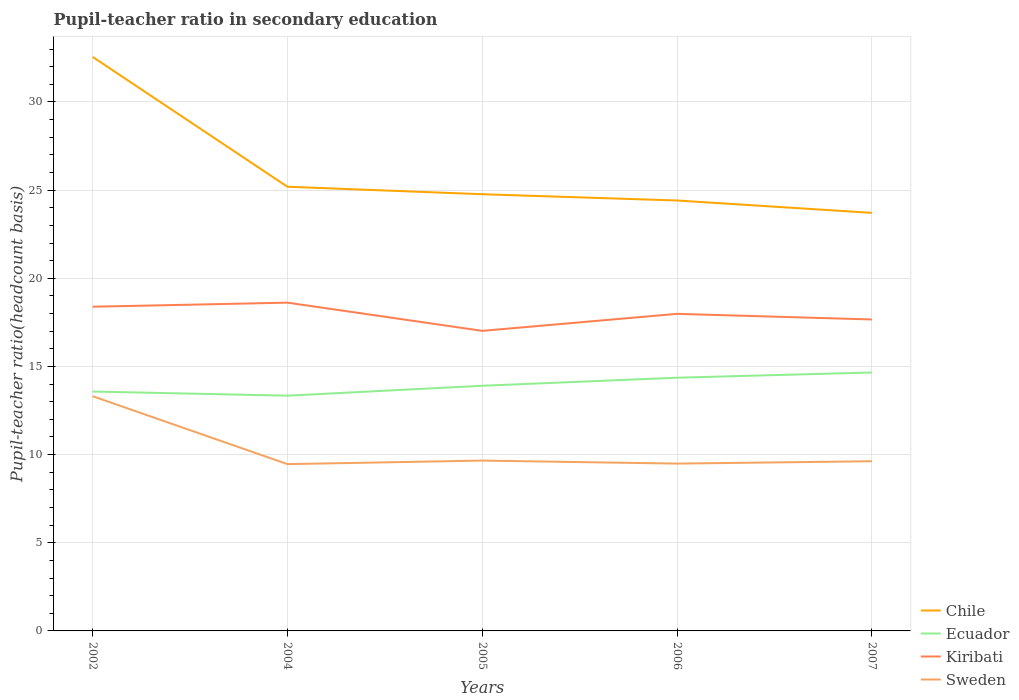Does the line corresponding to Chile intersect with the line corresponding to Kiribati?
Give a very brief answer. No. Across all years, what is the maximum pupil-teacher ratio in secondary education in Chile?
Your response must be concise. 23.71. What is the total pupil-teacher ratio in secondary education in Ecuador in the graph?
Keep it short and to the point. -1.31. What is the difference between the highest and the second highest pupil-teacher ratio in secondary education in Sweden?
Provide a succinct answer. 3.85. How many years are there in the graph?
Give a very brief answer. 5. What is the difference between two consecutive major ticks on the Y-axis?
Your answer should be compact. 5. Are the values on the major ticks of Y-axis written in scientific E-notation?
Keep it short and to the point. No. Does the graph contain grids?
Ensure brevity in your answer.  Yes. What is the title of the graph?
Offer a terse response. Pupil-teacher ratio in secondary education. Does "Malawi" appear as one of the legend labels in the graph?
Keep it short and to the point. No. What is the label or title of the X-axis?
Give a very brief answer. Years. What is the label or title of the Y-axis?
Offer a terse response. Pupil-teacher ratio(headcount basis). What is the Pupil-teacher ratio(headcount basis) of Chile in 2002?
Your answer should be compact. 32.56. What is the Pupil-teacher ratio(headcount basis) in Ecuador in 2002?
Your response must be concise. 13.58. What is the Pupil-teacher ratio(headcount basis) in Kiribati in 2002?
Provide a short and direct response. 18.39. What is the Pupil-teacher ratio(headcount basis) in Sweden in 2002?
Offer a terse response. 13.31. What is the Pupil-teacher ratio(headcount basis) of Chile in 2004?
Your response must be concise. 25.19. What is the Pupil-teacher ratio(headcount basis) of Ecuador in 2004?
Keep it short and to the point. 13.34. What is the Pupil-teacher ratio(headcount basis) of Kiribati in 2004?
Make the answer very short. 18.62. What is the Pupil-teacher ratio(headcount basis) of Sweden in 2004?
Ensure brevity in your answer.  9.46. What is the Pupil-teacher ratio(headcount basis) in Chile in 2005?
Provide a short and direct response. 24.77. What is the Pupil-teacher ratio(headcount basis) of Ecuador in 2005?
Your answer should be compact. 13.9. What is the Pupil-teacher ratio(headcount basis) of Kiribati in 2005?
Offer a very short reply. 17.02. What is the Pupil-teacher ratio(headcount basis) of Sweden in 2005?
Your response must be concise. 9.66. What is the Pupil-teacher ratio(headcount basis) in Chile in 2006?
Your answer should be compact. 24.41. What is the Pupil-teacher ratio(headcount basis) in Ecuador in 2006?
Your answer should be compact. 14.36. What is the Pupil-teacher ratio(headcount basis) in Kiribati in 2006?
Ensure brevity in your answer.  17.98. What is the Pupil-teacher ratio(headcount basis) of Sweden in 2006?
Offer a terse response. 9.49. What is the Pupil-teacher ratio(headcount basis) of Chile in 2007?
Give a very brief answer. 23.71. What is the Pupil-teacher ratio(headcount basis) of Ecuador in 2007?
Give a very brief answer. 14.66. What is the Pupil-teacher ratio(headcount basis) in Kiribati in 2007?
Make the answer very short. 17.66. What is the Pupil-teacher ratio(headcount basis) in Sweden in 2007?
Offer a very short reply. 9.62. Across all years, what is the maximum Pupil-teacher ratio(headcount basis) in Chile?
Provide a succinct answer. 32.56. Across all years, what is the maximum Pupil-teacher ratio(headcount basis) of Ecuador?
Ensure brevity in your answer.  14.66. Across all years, what is the maximum Pupil-teacher ratio(headcount basis) in Kiribati?
Your answer should be very brief. 18.62. Across all years, what is the maximum Pupil-teacher ratio(headcount basis) of Sweden?
Provide a succinct answer. 13.31. Across all years, what is the minimum Pupil-teacher ratio(headcount basis) in Chile?
Offer a terse response. 23.71. Across all years, what is the minimum Pupil-teacher ratio(headcount basis) of Ecuador?
Make the answer very short. 13.34. Across all years, what is the minimum Pupil-teacher ratio(headcount basis) in Kiribati?
Your answer should be compact. 17.02. Across all years, what is the minimum Pupil-teacher ratio(headcount basis) of Sweden?
Your answer should be compact. 9.46. What is the total Pupil-teacher ratio(headcount basis) of Chile in the graph?
Keep it short and to the point. 130.64. What is the total Pupil-teacher ratio(headcount basis) in Ecuador in the graph?
Your answer should be very brief. 69.84. What is the total Pupil-teacher ratio(headcount basis) of Kiribati in the graph?
Your answer should be compact. 89.67. What is the total Pupil-teacher ratio(headcount basis) of Sweden in the graph?
Make the answer very short. 51.55. What is the difference between the Pupil-teacher ratio(headcount basis) of Chile in 2002 and that in 2004?
Your answer should be very brief. 7.36. What is the difference between the Pupil-teacher ratio(headcount basis) in Ecuador in 2002 and that in 2004?
Provide a short and direct response. 0.23. What is the difference between the Pupil-teacher ratio(headcount basis) in Kiribati in 2002 and that in 2004?
Your answer should be very brief. -0.23. What is the difference between the Pupil-teacher ratio(headcount basis) of Sweden in 2002 and that in 2004?
Your answer should be compact. 3.85. What is the difference between the Pupil-teacher ratio(headcount basis) in Chile in 2002 and that in 2005?
Ensure brevity in your answer.  7.79. What is the difference between the Pupil-teacher ratio(headcount basis) of Ecuador in 2002 and that in 2005?
Keep it short and to the point. -0.33. What is the difference between the Pupil-teacher ratio(headcount basis) in Kiribati in 2002 and that in 2005?
Provide a succinct answer. 1.37. What is the difference between the Pupil-teacher ratio(headcount basis) in Sweden in 2002 and that in 2005?
Provide a succinct answer. 3.65. What is the difference between the Pupil-teacher ratio(headcount basis) in Chile in 2002 and that in 2006?
Your answer should be compact. 8.14. What is the difference between the Pupil-teacher ratio(headcount basis) of Ecuador in 2002 and that in 2006?
Your response must be concise. -0.78. What is the difference between the Pupil-teacher ratio(headcount basis) of Kiribati in 2002 and that in 2006?
Keep it short and to the point. 0.4. What is the difference between the Pupil-teacher ratio(headcount basis) of Sweden in 2002 and that in 2006?
Make the answer very short. 3.82. What is the difference between the Pupil-teacher ratio(headcount basis) of Chile in 2002 and that in 2007?
Offer a very short reply. 8.84. What is the difference between the Pupil-teacher ratio(headcount basis) of Ecuador in 2002 and that in 2007?
Give a very brief answer. -1.08. What is the difference between the Pupil-teacher ratio(headcount basis) of Kiribati in 2002 and that in 2007?
Keep it short and to the point. 0.72. What is the difference between the Pupil-teacher ratio(headcount basis) of Sweden in 2002 and that in 2007?
Your answer should be compact. 3.69. What is the difference between the Pupil-teacher ratio(headcount basis) in Chile in 2004 and that in 2005?
Offer a terse response. 0.42. What is the difference between the Pupil-teacher ratio(headcount basis) of Ecuador in 2004 and that in 2005?
Offer a terse response. -0.56. What is the difference between the Pupil-teacher ratio(headcount basis) of Kiribati in 2004 and that in 2005?
Offer a terse response. 1.6. What is the difference between the Pupil-teacher ratio(headcount basis) in Sweden in 2004 and that in 2005?
Make the answer very short. -0.2. What is the difference between the Pupil-teacher ratio(headcount basis) in Chile in 2004 and that in 2006?
Ensure brevity in your answer.  0.78. What is the difference between the Pupil-teacher ratio(headcount basis) of Ecuador in 2004 and that in 2006?
Make the answer very short. -1.02. What is the difference between the Pupil-teacher ratio(headcount basis) in Kiribati in 2004 and that in 2006?
Provide a short and direct response. 0.63. What is the difference between the Pupil-teacher ratio(headcount basis) in Sweden in 2004 and that in 2006?
Offer a terse response. -0.03. What is the difference between the Pupil-teacher ratio(headcount basis) in Chile in 2004 and that in 2007?
Your answer should be compact. 1.48. What is the difference between the Pupil-teacher ratio(headcount basis) of Ecuador in 2004 and that in 2007?
Your response must be concise. -1.31. What is the difference between the Pupil-teacher ratio(headcount basis) of Kiribati in 2004 and that in 2007?
Your response must be concise. 0.95. What is the difference between the Pupil-teacher ratio(headcount basis) in Sweden in 2004 and that in 2007?
Offer a terse response. -0.16. What is the difference between the Pupil-teacher ratio(headcount basis) of Chile in 2005 and that in 2006?
Make the answer very short. 0.36. What is the difference between the Pupil-teacher ratio(headcount basis) of Ecuador in 2005 and that in 2006?
Keep it short and to the point. -0.46. What is the difference between the Pupil-teacher ratio(headcount basis) of Kiribati in 2005 and that in 2006?
Give a very brief answer. -0.96. What is the difference between the Pupil-teacher ratio(headcount basis) of Sweden in 2005 and that in 2006?
Make the answer very short. 0.17. What is the difference between the Pupil-teacher ratio(headcount basis) of Chile in 2005 and that in 2007?
Provide a succinct answer. 1.06. What is the difference between the Pupil-teacher ratio(headcount basis) in Ecuador in 2005 and that in 2007?
Ensure brevity in your answer.  -0.75. What is the difference between the Pupil-teacher ratio(headcount basis) in Kiribati in 2005 and that in 2007?
Offer a very short reply. -0.65. What is the difference between the Pupil-teacher ratio(headcount basis) in Sweden in 2005 and that in 2007?
Offer a very short reply. 0.04. What is the difference between the Pupil-teacher ratio(headcount basis) in Chile in 2006 and that in 2007?
Ensure brevity in your answer.  0.7. What is the difference between the Pupil-teacher ratio(headcount basis) in Ecuador in 2006 and that in 2007?
Your response must be concise. -0.3. What is the difference between the Pupil-teacher ratio(headcount basis) of Kiribati in 2006 and that in 2007?
Give a very brief answer. 0.32. What is the difference between the Pupil-teacher ratio(headcount basis) in Sweden in 2006 and that in 2007?
Provide a succinct answer. -0.13. What is the difference between the Pupil-teacher ratio(headcount basis) of Chile in 2002 and the Pupil-teacher ratio(headcount basis) of Ecuador in 2004?
Provide a short and direct response. 19.21. What is the difference between the Pupil-teacher ratio(headcount basis) in Chile in 2002 and the Pupil-teacher ratio(headcount basis) in Kiribati in 2004?
Offer a very short reply. 13.94. What is the difference between the Pupil-teacher ratio(headcount basis) of Chile in 2002 and the Pupil-teacher ratio(headcount basis) of Sweden in 2004?
Make the answer very short. 23.1. What is the difference between the Pupil-teacher ratio(headcount basis) of Ecuador in 2002 and the Pupil-teacher ratio(headcount basis) of Kiribati in 2004?
Make the answer very short. -5.04. What is the difference between the Pupil-teacher ratio(headcount basis) in Ecuador in 2002 and the Pupil-teacher ratio(headcount basis) in Sweden in 2004?
Provide a succinct answer. 4.12. What is the difference between the Pupil-teacher ratio(headcount basis) of Kiribati in 2002 and the Pupil-teacher ratio(headcount basis) of Sweden in 2004?
Your answer should be very brief. 8.93. What is the difference between the Pupil-teacher ratio(headcount basis) of Chile in 2002 and the Pupil-teacher ratio(headcount basis) of Ecuador in 2005?
Offer a very short reply. 18.65. What is the difference between the Pupil-teacher ratio(headcount basis) of Chile in 2002 and the Pupil-teacher ratio(headcount basis) of Kiribati in 2005?
Give a very brief answer. 15.54. What is the difference between the Pupil-teacher ratio(headcount basis) of Chile in 2002 and the Pupil-teacher ratio(headcount basis) of Sweden in 2005?
Your answer should be compact. 22.89. What is the difference between the Pupil-teacher ratio(headcount basis) of Ecuador in 2002 and the Pupil-teacher ratio(headcount basis) of Kiribati in 2005?
Make the answer very short. -3.44. What is the difference between the Pupil-teacher ratio(headcount basis) in Ecuador in 2002 and the Pupil-teacher ratio(headcount basis) in Sweden in 2005?
Your answer should be compact. 3.92. What is the difference between the Pupil-teacher ratio(headcount basis) of Kiribati in 2002 and the Pupil-teacher ratio(headcount basis) of Sweden in 2005?
Offer a terse response. 8.73. What is the difference between the Pupil-teacher ratio(headcount basis) in Chile in 2002 and the Pupil-teacher ratio(headcount basis) in Ecuador in 2006?
Offer a terse response. 18.19. What is the difference between the Pupil-teacher ratio(headcount basis) of Chile in 2002 and the Pupil-teacher ratio(headcount basis) of Kiribati in 2006?
Ensure brevity in your answer.  14.57. What is the difference between the Pupil-teacher ratio(headcount basis) of Chile in 2002 and the Pupil-teacher ratio(headcount basis) of Sweden in 2006?
Make the answer very short. 23.06. What is the difference between the Pupil-teacher ratio(headcount basis) of Ecuador in 2002 and the Pupil-teacher ratio(headcount basis) of Kiribati in 2006?
Offer a terse response. -4.41. What is the difference between the Pupil-teacher ratio(headcount basis) in Ecuador in 2002 and the Pupil-teacher ratio(headcount basis) in Sweden in 2006?
Provide a short and direct response. 4.09. What is the difference between the Pupil-teacher ratio(headcount basis) in Kiribati in 2002 and the Pupil-teacher ratio(headcount basis) in Sweden in 2006?
Your answer should be compact. 8.9. What is the difference between the Pupil-teacher ratio(headcount basis) of Chile in 2002 and the Pupil-teacher ratio(headcount basis) of Ecuador in 2007?
Your answer should be very brief. 17.9. What is the difference between the Pupil-teacher ratio(headcount basis) of Chile in 2002 and the Pupil-teacher ratio(headcount basis) of Kiribati in 2007?
Ensure brevity in your answer.  14.89. What is the difference between the Pupil-teacher ratio(headcount basis) of Chile in 2002 and the Pupil-teacher ratio(headcount basis) of Sweden in 2007?
Offer a terse response. 22.93. What is the difference between the Pupil-teacher ratio(headcount basis) in Ecuador in 2002 and the Pupil-teacher ratio(headcount basis) in Kiribati in 2007?
Your answer should be very brief. -4.09. What is the difference between the Pupil-teacher ratio(headcount basis) in Ecuador in 2002 and the Pupil-teacher ratio(headcount basis) in Sweden in 2007?
Make the answer very short. 3.95. What is the difference between the Pupil-teacher ratio(headcount basis) of Kiribati in 2002 and the Pupil-teacher ratio(headcount basis) of Sweden in 2007?
Ensure brevity in your answer.  8.76. What is the difference between the Pupil-teacher ratio(headcount basis) in Chile in 2004 and the Pupil-teacher ratio(headcount basis) in Ecuador in 2005?
Keep it short and to the point. 11.29. What is the difference between the Pupil-teacher ratio(headcount basis) in Chile in 2004 and the Pupil-teacher ratio(headcount basis) in Kiribati in 2005?
Give a very brief answer. 8.17. What is the difference between the Pupil-teacher ratio(headcount basis) in Chile in 2004 and the Pupil-teacher ratio(headcount basis) in Sweden in 2005?
Your answer should be very brief. 15.53. What is the difference between the Pupil-teacher ratio(headcount basis) in Ecuador in 2004 and the Pupil-teacher ratio(headcount basis) in Kiribati in 2005?
Give a very brief answer. -3.68. What is the difference between the Pupil-teacher ratio(headcount basis) in Ecuador in 2004 and the Pupil-teacher ratio(headcount basis) in Sweden in 2005?
Give a very brief answer. 3.68. What is the difference between the Pupil-teacher ratio(headcount basis) of Kiribati in 2004 and the Pupil-teacher ratio(headcount basis) of Sweden in 2005?
Give a very brief answer. 8.96. What is the difference between the Pupil-teacher ratio(headcount basis) of Chile in 2004 and the Pupil-teacher ratio(headcount basis) of Ecuador in 2006?
Give a very brief answer. 10.83. What is the difference between the Pupil-teacher ratio(headcount basis) of Chile in 2004 and the Pupil-teacher ratio(headcount basis) of Kiribati in 2006?
Offer a terse response. 7.21. What is the difference between the Pupil-teacher ratio(headcount basis) in Chile in 2004 and the Pupil-teacher ratio(headcount basis) in Sweden in 2006?
Provide a short and direct response. 15.7. What is the difference between the Pupil-teacher ratio(headcount basis) of Ecuador in 2004 and the Pupil-teacher ratio(headcount basis) of Kiribati in 2006?
Your answer should be very brief. -4.64. What is the difference between the Pupil-teacher ratio(headcount basis) of Ecuador in 2004 and the Pupil-teacher ratio(headcount basis) of Sweden in 2006?
Your answer should be compact. 3.85. What is the difference between the Pupil-teacher ratio(headcount basis) in Kiribati in 2004 and the Pupil-teacher ratio(headcount basis) in Sweden in 2006?
Provide a succinct answer. 9.13. What is the difference between the Pupil-teacher ratio(headcount basis) in Chile in 2004 and the Pupil-teacher ratio(headcount basis) in Ecuador in 2007?
Offer a terse response. 10.54. What is the difference between the Pupil-teacher ratio(headcount basis) in Chile in 2004 and the Pupil-teacher ratio(headcount basis) in Kiribati in 2007?
Provide a succinct answer. 7.53. What is the difference between the Pupil-teacher ratio(headcount basis) in Chile in 2004 and the Pupil-teacher ratio(headcount basis) in Sweden in 2007?
Provide a short and direct response. 15.57. What is the difference between the Pupil-teacher ratio(headcount basis) in Ecuador in 2004 and the Pupil-teacher ratio(headcount basis) in Kiribati in 2007?
Give a very brief answer. -4.32. What is the difference between the Pupil-teacher ratio(headcount basis) in Ecuador in 2004 and the Pupil-teacher ratio(headcount basis) in Sweden in 2007?
Keep it short and to the point. 3.72. What is the difference between the Pupil-teacher ratio(headcount basis) in Kiribati in 2004 and the Pupil-teacher ratio(headcount basis) in Sweden in 2007?
Your answer should be compact. 8.99. What is the difference between the Pupil-teacher ratio(headcount basis) in Chile in 2005 and the Pupil-teacher ratio(headcount basis) in Ecuador in 2006?
Offer a terse response. 10.41. What is the difference between the Pupil-teacher ratio(headcount basis) of Chile in 2005 and the Pupil-teacher ratio(headcount basis) of Kiribati in 2006?
Offer a terse response. 6.78. What is the difference between the Pupil-teacher ratio(headcount basis) in Chile in 2005 and the Pupil-teacher ratio(headcount basis) in Sweden in 2006?
Give a very brief answer. 15.28. What is the difference between the Pupil-teacher ratio(headcount basis) in Ecuador in 2005 and the Pupil-teacher ratio(headcount basis) in Kiribati in 2006?
Your answer should be very brief. -4.08. What is the difference between the Pupil-teacher ratio(headcount basis) of Ecuador in 2005 and the Pupil-teacher ratio(headcount basis) of Sweden in 2006?
Keep it short and to the point. 4.41. What is the difference between the Pupil-teacher ratio(headcount basis) of Kiribati in 2005 and the Pupil-teacher ratio(headcount basis) of Sweden in 2006?
Your response must be concise. 7.53. What is the difference between the Pupil-teacher ratio(headcount basis) in Chile in 2005 and the Pupil-teacher ratio(headcount basis) in Ecuador in 2007?
Ensure brevity in your answer.  10.11. What is the difference between the Pupil-teacher ratio(headcount basis) in Chile in 2005 and the Pupil-teacher ratio(headcount basis) in Kiribati in 2007?
Your answer should be very brief. 7.1. What is the difference between the Pupil-teacher ratio(headcount basis) of Chile in 2005 and the Pupil-teacher ratio(headcount basis) of Sweden in 2007?
Ensure brevity in your answer.  15.14. What is the difference between the Pupil-teacher ratio(headcount basis) of Ecuador in 2005 and the Pupil-teacher ratio(headcount basis) of Kiribati in 2007?
Your answer should be very brief. -3.76. What is the difference between the Pupil-teacher ratio(headcount basis) of Ecuador in 2005 and the Pupil-teacher ratio(headcount basis) of Sweden in 2007?
Your response must be concise. 4.28. What is the difference between the Pupil-teacher ratio(headcount basis) in Kiribati in 2005 and the Pupil-teacher ratio(headcount basis) in Sweden in 2007?
Offer a very short reply. 7.39. What is the difference between the Pupil-teacher ratio(headcount basis) of Chile in 2006 and the Pupil-teacher ratio(headcount basis) of Ecuador in 2007?
Make the answer very short. 9.76. What is the difference between the Pupil-teacher ratio(headcount basis) in Chile in 2006 and the Pupil-teacher ratio(headcount basis) in Kiribati in 2007?
Your answer should be very brief. 6.75. What is the difference between the Pupil-teacher ratio(headcount basis) in Chile in 2006 and the Pupil-teacher ratio(headcount basis) in Sweden in 2007?
Keep it short and to the point. 14.79. What is the difference between the Pupil-teacher ratio(headcount basis) in Ecuador in 2006 and the Pupil-teacher ratio(headcount basis) in Kiribati in 2007?
Provide a short and direct response. -3.3. What is the difference between the Pupil-teacher ratio(headcount basis) in Ecuador in 2006 and the Pupil-teacher ratio(headcount basis) in Sweden in 2007?
Provide a short and direct response. 4.74. What is the difference between the Pupil-teacher ratio(headcount basis) of Kiribati in 2006 and the Pupil-teacher ratio(headcount basis) of Sweden in 2007?
Your answer should be very brief. 8.36. What is the average Pupil-teacher ratio(headcount basis) in Chile per year?
Make the answer very short. 26.13. What is the average Pupil-teacher ratio(headcount basis) of Ecuador per year?
Provide a short and direct response. 13.97. What is the average Pupil-teacher ratio(headcount basis) in Kiribati per year?
Your answer should be compact. 17.93. What is the average Pupil-teacher ratio(headcount basis) in Sweden per year?
Your answer should be compact. 10.31. In the year 2002, what is the difference between the Pupil-teacher ratio(headcount basis) in Chile and Pupil-teacher ratio(headcount basis) in Ecuador?
Keep it short and to the point. 18.98. In the year 2002, what is the difference between the Pupil-teacher ratio(headcount basis) of Chile and Pupil-teacher ratio(headcount basis) of Kiribati?
Keep it short and to the point. 14.17. In the year 2002, what is the difference between the Pupil-teacher ratio(headcount basis) in Chile and Pupil-teacher ratio(headcount basis) in Sweden?
Provide a short and direct response. 19.24. In the year 2002, what is the difference between the Pupil-teacher ratio(headcount basis) in Ecuador and Pupil-teacher ratio(headcount basis) in Kiribati?
Your answer should be compact. -4.81. In the year 2002, what is the difference between the Pupil-teacher ratio(headcount basis) of Ecuador and Pupil-teacher ratio(headcount basis) of Sweden?
Offer a terse response. 0.27. In the year 2002, what is the difference between the Pupil-teacher ratio(headcount basis) in Kiribati and Pupil-teacher ratio(headcount basis) in Sweden?
Make the answer very short. 5.08. In the year 2004, what is the difference between the Pupil-teacher ratio(headcount basis) in Chile and Pupil-teacher ratio(headcount basis) in Ecuador?
Offer a very short reply. 11.85. In the year 2004, what is the difference between the Pupil-teacher ratio(headcount basis) of Chile and Pupil-teacher ratio(headcount basis) of Kiribati?
Your answer should be very brief. 6.57. In the year 2004, what is the difference between the Pupil-teacher ratio(headcount basis) of Chile and Pupil-teacher ratio(headcount basis) of Sweden?
Your answer should be compact. 15.73. In the year 2004, what is the difference between the Pupil-teacher ratio(headcount basis) in Ecuador and Pupil-teacher ratio(headcount basis) in Kiribati?
Ensure brevity in your answer.  -5.28. In the year 2004, what is the difference between the Pupil-teacher ratio(headcount basis) in Ecuador and Pupil-teacher ratio(headcount basis) in Sweden?
Ensure brevity in your answer.  3.88. In the year 2004, what is the difference between the Pupil-teacher ratio(headcount basis) in Kiribati and Pupil-teacher ratio(headcount basis) in Sweden?
Offer a very short reply. 9.16. In the year 2005, what is the difference between the Pupil-teacher ratio(headcount basis) in Chile and Pupil-teacher ratio(headcount basis) in Ecuador?
Your answer should be very brief. 10.86. In the year 2005, what is the difference between the Pupil-teacher ratio(headcount basis) in Chile and Pupil-teacher ratio(headcount basis) in Kiribati?
Provide a short and direct response. 7.75. In the year 2005, what is the difference between the Pupil-teacher ratio(headcount basis) in Chile and Pupil-teacher ratio(headcount basis) in Sweden?
Offer a terse response. 15.11. In the year 2005, what is the difference between the Pupil-teacher ratio(headcount basis) of Ecuador and Pupil-teacher ratio(headcount basis) of Kiribati?
Keep it short and to the point. -3.11. In the year 2005, what is the difference between the Pupil-teacher ratio(headcount basis) in Ecuador and Pupil-teacher ratio(headcount basis) in Sweden?
Your answer should be very brief. 4.24. In the year 2005, what is the difference between the Pupil-teacher ratio(headcount basis) in Kiribati and Pupil-teacher ratio(headcount basis) in Sweden?
Give a very brief answer. 7.36. In the year 2006, what is the difference between the Pupil-teacher ratio(headcount basis) of Chile and Pupil-teacher ratio(headcount basis) of Ecuador?
Your answer should be compact. 10.05. In the year 2006, what is the difference between the Pupil-teacher ratio(headcount basis) in Chile and Pupil-teacher ratio(headcount basis) in Kiribati?
Provide a succinct answer. 6.43. In the year 2006, what is the difference between the Pupil-teacher ratio(headcount basis) in Chile and Pupil-teacher ratio(headcount basis) in Sweden?
Provide a succinct answer. 14.92. In the year 2006, what is the difference between the Pupil-teacher ratio(headcount basis) in Ecuador and Pupil-teacher ratio(headcount basis) in Kiribati?
Your response must be concise. -3.62. In the year 2006, what is the difference between the Pupil-teacher ratio(headcount basis) in Ecuador and Pupil-teacher ratio(headcount basis) in Sweden?
Give a very brief answer. 4.87. In the year 2006, what is the difference between the Pupil-teacher ratio(headcount basis) of Kiribati and Pupil-teacher ratio(headcount basis) of Sweden?
Make the answer very short. 8.49. In the year 2007, what is the difference between the Pupil-teacher ratio(headcount basis) of Chile and Pupil-teacher ratio(headcount basis) of Ecuador?
Keep it short and to the point. 9.05. In the year 2007, what is the difference between the Pupil-teacher ratio(headcount basis) in Chile and Pupil-teacher ratio(headcount basis) in Kiribati?
Offer a very short reply. 6.05. In the year 2007, what is the difference between the Pupil-teacher ratio(headcount basis) in Chile and Pupil-teacher ratio(headcount basis) in Sweden?
Your answer should be very brief. 14.09. In the year 2007, what is the difference between the Pupil-teacher ratio(headcount basis) in Ecuador and Pupil-teacher ratio(headcount basis) in Kiribati?
Provide a succinct answer. -3.01. In the year 2007, what is the difference between the Pupil-teacher ratio(headcount basis) in Ecuador and Pupil-teacher ratio(headcount basis) in Sweden?
Your answer should be very brief. 5.03. In the year 2007, what is the difference between the Pupil-teacher ratio(headcount basis) in Kiribati and Pupil-teacher ratio(headcount basis) in Sweden?
Make the answer very short. 8.04. What is the ratio of the Pupil-teacher ratio(headcount basis) of Chile in 2002 to that in 2004?
Your answer should be compact. 1.29. What is the ratio of the Pupil-teacher ratio(headcount basis) in Ecuador in 2002 to that in 2004?
Provide a succinct answer. 1.02. What is the ratio of the Pupil-teacher ratio(headcount basis) in Kiribati in 2002 to that in 2004?
Keep it short and to the point. 0.99. What is the ratio of the Pupil-teacher ratio(headcount basis) of Sweden in 2002 to that in 2004?
Make the answer very short. 1.41. What is the ratio of the Pupil-teacher ratio(headcount basis) of Chile in 2002 to that in 2005?
Your answer should be compact. 1.31. What is the ratio of the Pupil-teacher ratio(headcount basis) in Ecuador in 2002 to that in 2005?
Ensure brevity in your answer.  0.98. What is the ratio of the Pupil-teacher ratio(headcount basis) of Kiribati in 2002 to that in 2005?
Offer a very short reply. 1.08. What is the ratio of the Pupil-teacher ratio(headcount basis) of Sweden in 2002 to that in 2005?
Keep it short and to the point. 1.38. What is the ratio of the Pupil-teacher ratio(headcount basis) of Chile in 2002 to that in 2006?
Your answer should be compact. 1.33. What is the ratio of the Pupil-teacher ratio(headcount basis) of Ecuador in 2002 to that in 2006?
Your response must be concise. 0.95. What is the ratio of the Pupil-teacher ratio(headcount basis) of Kiribati in 2002 to that in 2006?
Make the answer very short. 1.02. What is the ratio of the Pupil-teacher ratio(headcount basis) in Sweden in 2002 to that in 2006?
Keep it short and to the point. 1.4. What is the ratio of the Pupil-teacher ratio(headcount basis) of Chile in 2002 to that in 2007?
Ensure brevity in your answer.  1.37. What is the ratio of the Pupil-teacher ratio(headcount basis) of Ecuador in 2002 to that in 2007?
Provide a succinct answer. 0.93. What is the ratio of the Pupil-teacher ratio(headcount basis) of Kiribati in 2002 to that in 2007?
Keep it short and to the point. 1.04. What is the ratio of the Pupil-teacher ratio(headcount basis) in Sweden in 2002 to that in 2007?
Provide a short and direct response. 1.38. What is the ratio of the Pupil-teacher ratio(headcount basis) of Chile in 2004 to that in 2005?
Your answer should be very brief. 1.02. What is the ratio of the Pupil-teacher ratio(headcount basis) in Ecuador in 2004 to that in 2005?
Provide a short and direct response. 0.96. What is the ratio of the Pupil-teacher ratio(headcount basis) in Kiribati in 2004 to that in 2005?
Your response must be concise. 1.09. What is the ratio of the Pupil-teacher ratio(headcount basis) in Sweden in 2004 to that in 2005?
Offer a terse response. 0.98. What is the ratio of the Pupil-teacher ratio(headcount basis) in Chile in 2004 to that in 2006?
Keep it short and to the point. 1.03. What is the ratio of the Pupil-teacher ratio(headcount basis) of Ecuador in 2004 to that in 2006?
Offer a very short reply. 0.93. What is the ratio of the Pupil-teacher ratio(headcount basis) in Kiribati in 2004 to that in 2006?
Make the answer very short. 1.04. What is the ratio of the Pupil-teacher ratio(headcount basis) of Chile in 2004 to that in 2007?
Make the answer very short. 1.06. What is the ratio of the Pupil-teacher ratio(headcount basis) in Ecuador in 2004 to that in 2007?
Provide a short and direct response. 0.91. What is the ratio of the Pupil-teacher ratio(headcount basis) in Kiribati in 2004 to that in 2007?
Provide a succinct answer. 1.05. What is the ratio of the Pupil-teacher ratio(headcount basis) of Sweden in 2004 to that in 2007?
Your response must be concise. 0.98. What is the ratio of the Pupil-teacher ratio(headcount basis) in Chile in 2005 to that in 2006?
Your response must be concise. 1.01. What is the ratio of the Pupil-teacher ratio(headcount basis) in Ecuador in 2005 to that in 2006?
Your answer should be very brief. 0.97. What is the ratio of the Pupil-teacher ratio(headcount basis) in Kiribati in 2005 to that in 2006?
Give a very brief answer. 0.95. What is the ratio of the Pupil-teacher ratio(headcount basis) of Chile in 2005 to that in 2007?
Your response must be concise. 1.04. What is the ratio of the Pupil-teacher ratio(headcount basis) of Ecuador in 2005 to that in 2007?
Ensure brevity in your answer.  0.95. What is the ratio of the Pupil-teacher ratio(headcount basis) in Kiribati in 2005 to that in 2007?
Your response must be concise. 0.96. What is the ratio of the Pupil-teacher ratio(headcount basis) of Sweden in 2005 to that in 2007?
Offer a very short reply. 1. What is the ratio of the Pupil-teacher ratio(headcount basis) of Chile in 2006 to that in 2007?
Provide a short and direct response. 1.03. What is the ratio of the Pupil-teacher ratio(headcount basis) of Ecuador in 2006 to that in 2007?
Ensure brevity in your answer.  0.98. What is the ratio of the Pupil-teacher ratio(headcount basis) in Kiribati in 2006 to that in 2007?
Give a very brief answer. 1.02. What is the ratio of the Pupil-teacher ratio(headcount basis) of Sweden in 2006 to that in 2007?
Offer a terse response. 0.99. What is the difference between the highest and the second highest Pupil-teacher ratio(headcount basis) in Chile?
Ensure brevity in your answer.  7.36. What is the difference between the highest and the second highest Pupil-teacher ratio(headcount basis) of Ecuador?
Keep it short and to the point. 0.3. What is the difference between the highest and the second highest Pupil-teacher ratio(headcount basis) in Kiribati?
Provide a succinct answer. 0.23. What is the difference between the highest and the second highest Pupil-teacher ratio(headcount basis) of Sweden?
Give a very brief answer. 3.65. What is the difference between the highest and the lowest Pupil-teacher ratio(headcount basis) of Chile?
Provide a succinct answer. 8.84. What is the difference between the highest and the lowest Pupil-teacher ratio(headcount basis) of Ecuador?
Offer a very short reply. 1.31. What is the difference between the highest and the lowest Pupil-teacher ratio(headcount basis) of Kiribati?
Your answer should be very brief. 1.6. What is the difference between the highest and the lowest Pupil-teacher ratio(headcount basis) of Sweden?
Your answer should be very brief. 3.85. 